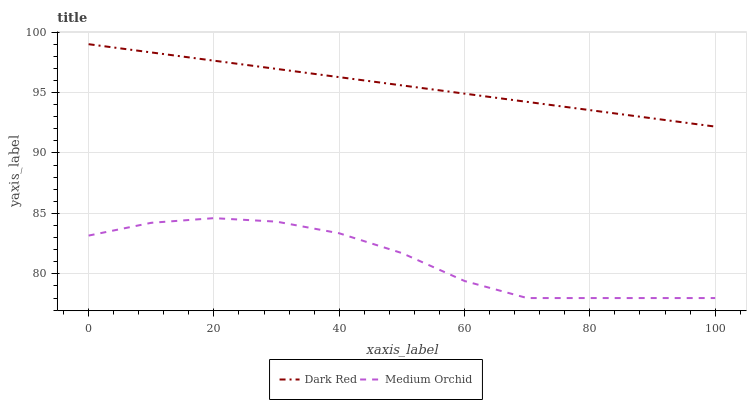Does Medium Orchid have the minimum area under the curve?
Answer yes or no. Yes. Does Dark Red have the maximum area under the curve?
Answer yes or no. Yes. Does Medium Orchid have the maximum area under the curve?
Answer yes or no. No. Is Dark Red the smoothest?
Answer yes or no. Yes. Is Medium Orchid the roughest?
Answer yes or no. Yes. Is Medium Orchid the smoothest?
Answer yes or no. No. Does Medium Orchid have the lowest value?
Answer yes or no. Yes. Does Dark Red have the highest value?
Answer yes or no. Yes. Does Medium Orchid have the highest value?
Answer yes or no. No. Is Medium Orchid less than Dark Red?
Answer yes or no. Yes. Is Dark Red greater than Medium Orchid?
Answer yes or no. Yes. Does Medium Orchid intersect Dark Red?
Answer yes or no. No. 